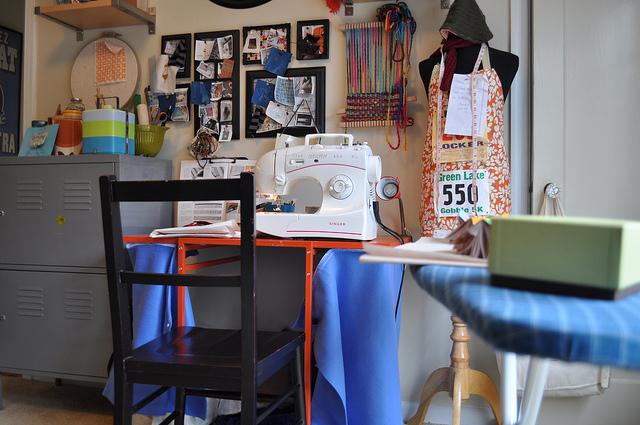What is done at the table?
Give a very brief answer. Sewing. Has this person entered any competitions?
Quick response, please. Yes. Is this a modern sewing machine?
Write a very short answer. Yes. 